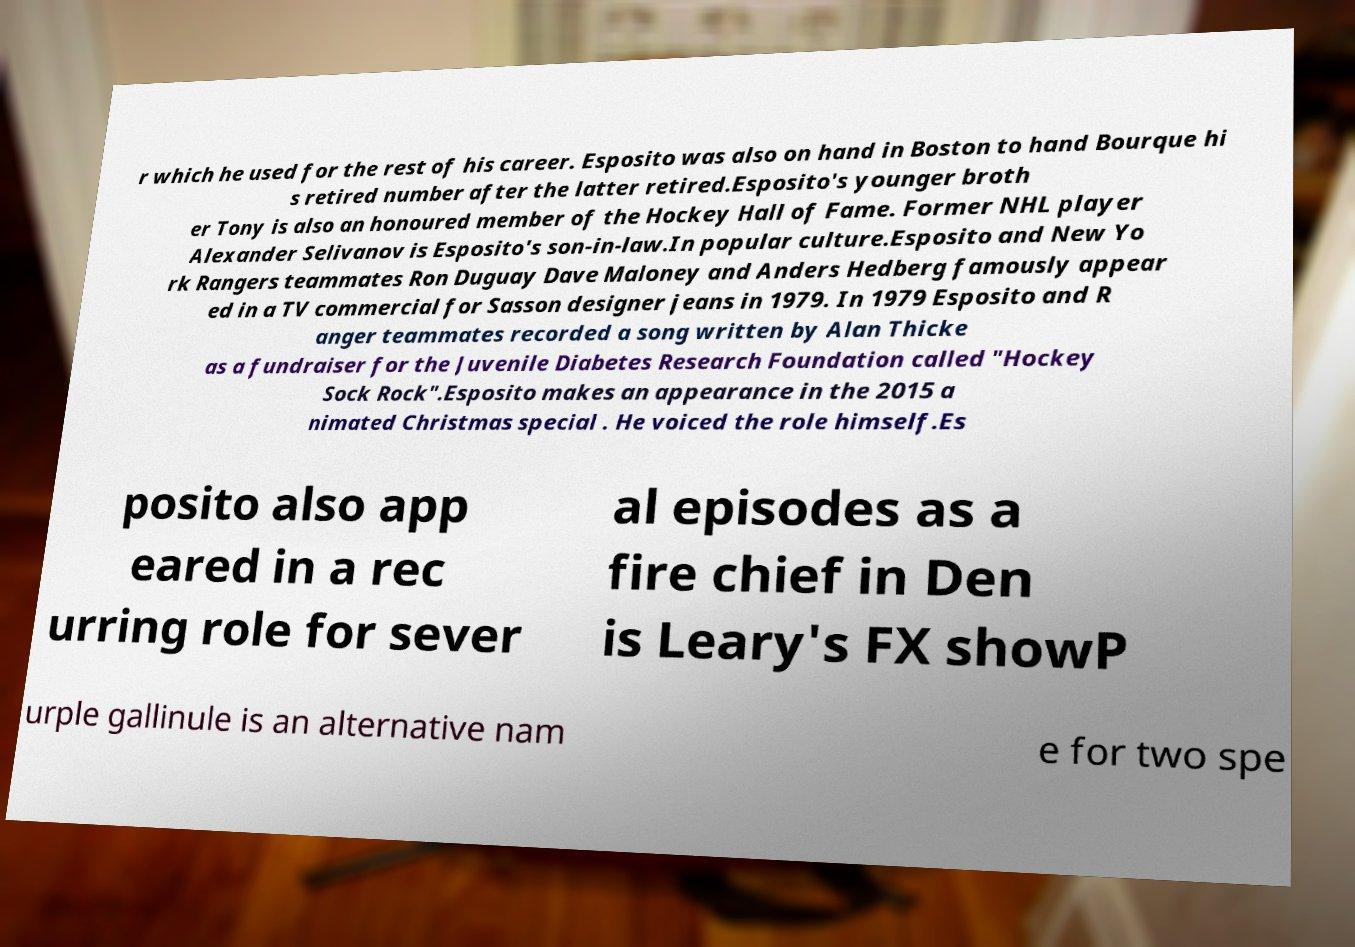Please read and relay the text visible in this image. What does it say? r which he used for the rest of his career. Esposito was also on hand in Boston to hand Bourque hi s retired number after the latter retired.Esposito's younger broth er Tony is also an honoured member of the Hockey Hall of Fame. Former NHL player Alexander Selivanov is Esposito's son-in-law.In popular culture.Esposito and New Yo rk Rangers teammates Ron Duguay Dave Maloney and Anders Hedberg famously appear ed in a TV commercial for Sasson designer jeans in 1979. In 1979 Esposito and R anger teammates recorded a song written by Alan Thicke as a fundraiser for the Juvenile Diabetes Research Foundation called "Hockey Sock Rock".Esposito makes an appearance in the 2015 a nimated Christmas special . He voiced the role himself.Es posito also app eared in a rec urring role for sever al episodes as a fire chief in Den is Leary's FX showP urple gallinule is an alternative nam e for two spe 